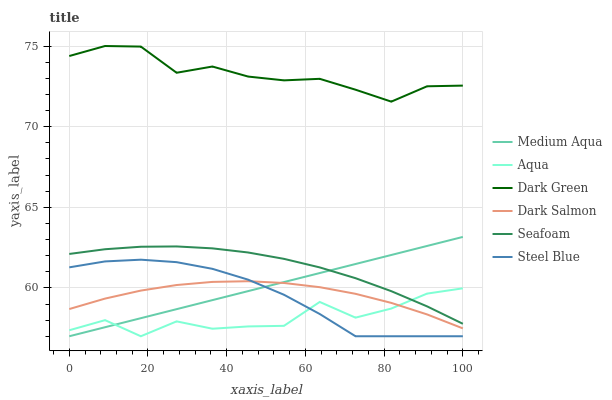Does Seafoam have the minimum area under the curve?
Answer yes or no. No. Does Seafoam have the maximum area under the curve?
Answer yes or no. No. Is Seafoam the smoothest?
Answer yes or no. No. Is Seafoam the roughest?
Answer yes or no. No. Does Seafoam have the lowest value?
Answer yes or no. No. Does Seafoam have the highest value?
Answer yes or no. No. Is Aqua less than Dark Green?
Answer yes or no. Yes. Is Dark Green greater than Medium Aqua?
Answer yes or no. Yes. Does Aqua intersect Dark Green?
Answer yes or no. No. 